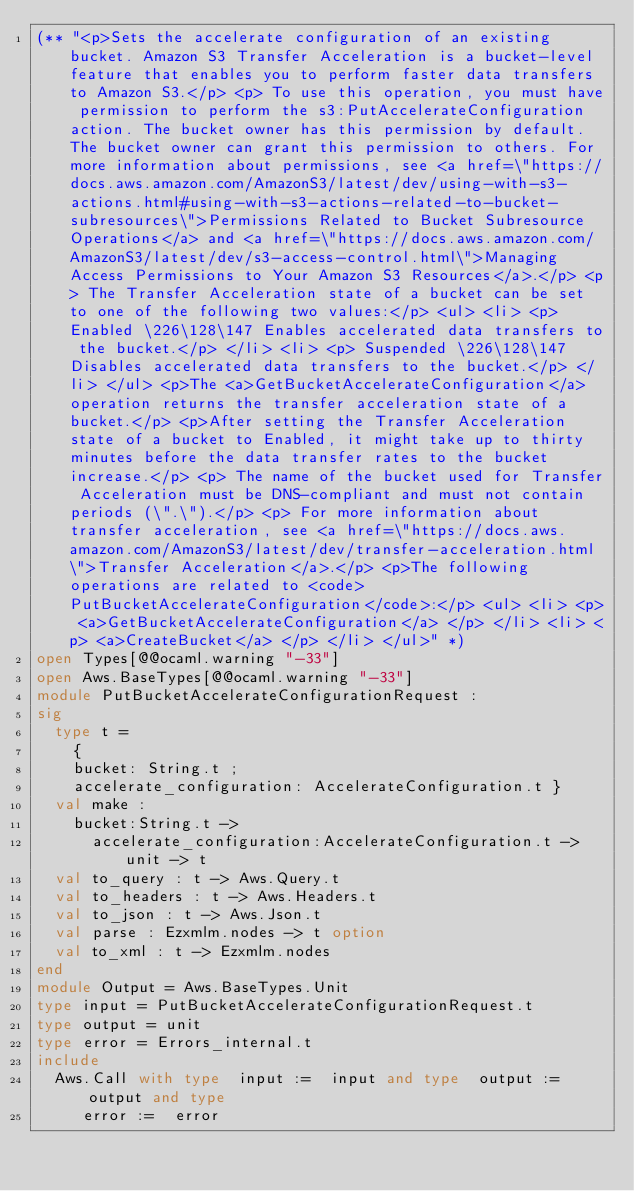Convert code to text. <code><loc_0><loc_0><loc_500><loc_500><_OCaml_>(** "<p>Sets the accelerate configuration of an existing bucket. Amazon S3 Transfer Acceleration is a bucket-level feature that enables you to perform faster data transfers to Amazon S3.</p> <p> To use this operation, you must have permission to perform the s3:PutAccelerateConfiguration action. The bucket owner has this permission by default. The bucket owner can grant this permission to others. For more information about permissions, see <a href=\"https://docs.aws.amazon.com/AmazonS3/latest/dev/using-with-s3-actions.html#using-with-s3-actions-related-to-bucket-subresources\">Permissions Related to Bucket Subresource Operations</a> and <a href=\"https://docs.aws.amazon.com/AmazonS3/latest/dev/s3-access-control.html\">Managing Access Permissions to Your Amazon S3 Resources</a>.</p> <p> The Transfer Acceleration state of a bucket can be set to one of the following two values:</p> <ul> <li> <p> Enabled \226\128\147 Enables accelerated data transfers to the bucket.</p> </li> <li> <p> Suspended \226\128\147 Disables accelerated data transfers to the bucket.</p> </li> </ul> <p>The <a>GetBucketAccelerateConfiguration</a> operation returns the transfer acceleration state of a bucket.</p> <p>After setting the Transfer Acceleration state of a bucket to Enabled, it might take up to thirty minutes before the data transfer rates to the bucket increase.</p> <p> The name of the bucket used for Transfer Acceleration must be DNS-compliant and must not contain periods (\".\").</p> <p> For more information about transfer acceleration, see <a href=\"https://docs.aws.amazon.com/AmazonS3/latest/dev/transfer-acceleration.html\">Transfer Acceleration</a>.</p> <p>The following operations are related to <code>PutBucketAccelerateConfiguration</code>:</p> <ul> <li> <p> <a>GetBucketAccelerateConfiguration</a> </p> </li> <li> <p> <a>CreateBucket</a> </p> </li> </ul>" *)
open Types[@@ocaml.warning "-33"]
open Aws.BaseTypes[@@ocaml.warning "-33"]
module PutBucketAccelerateConfigurationRequest :
sig
  type t =
    {
    bucket: String.t ;
    accelerate_configuration: AccelerateConfiguration.t }
  val make :
    bucket:String.t ->
      accelerate_configuration:AccelerateConfiguration.t -> unit -> t
  val to_query : t -> Aws.Query.t
  val to_headers : t -> Aws.Headers.t
  val to_json : t -> Aws.Json.t
  val parse : Ezxmlm.nodes -> t option
  val to_xml : t -> Ezxmlm.nodes
end
module Output = Aws.BaseTypes.Unit
type input = PutBucketAccelerateConfigurationRequest.t
type output = unit
type error = Errors_internal.t
include
  Aws.Call with type  input :=  input and type  output :=  output and type
     error :=  error</code> 